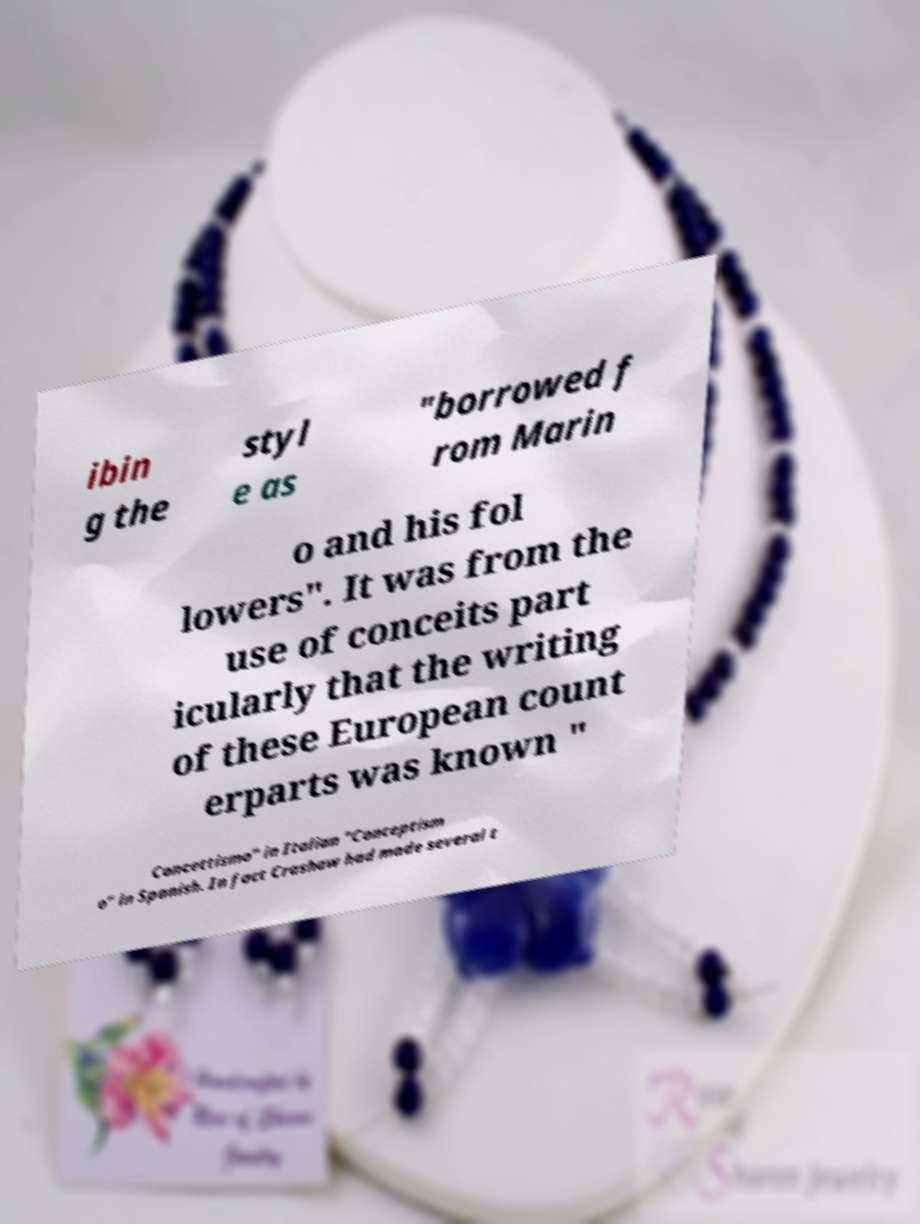There's text embedded in this image that I need extracted. Can you transcribe it verbatim? ibin g the styl e as "borrowed f rom Marin o and his fol lowers". It was from the use of conceits part icularly that the writing of these European count erparts was known " Concettismo" in Italian "Conceptism o" in Spanish. In fact Crashaw had made several t 